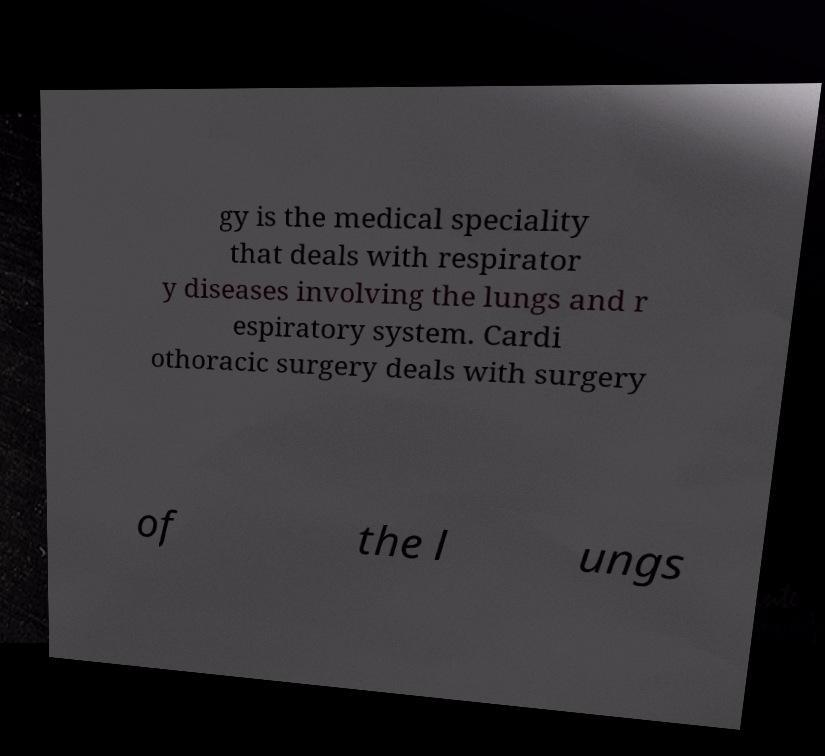Can you accurately transcribe the text from the provided image for me? gy is the medical speciality that deals with respirator y diseases involving the lungs and r espiratory system. Cardi othoracic surgery deals with surgery of the l ungs 